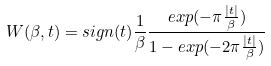<formula> <loc_0><loc_0><loc_500><loc_500>W ( \beta , t ) = s i g n ( t ) \frac { 1 } { \beta } \frac { e x p ( - \pi \frac { | t | } { \beta } ) } { 1 - e x p ( - 2 \pi \frac { | t | } { \beta } ) }</formula> 